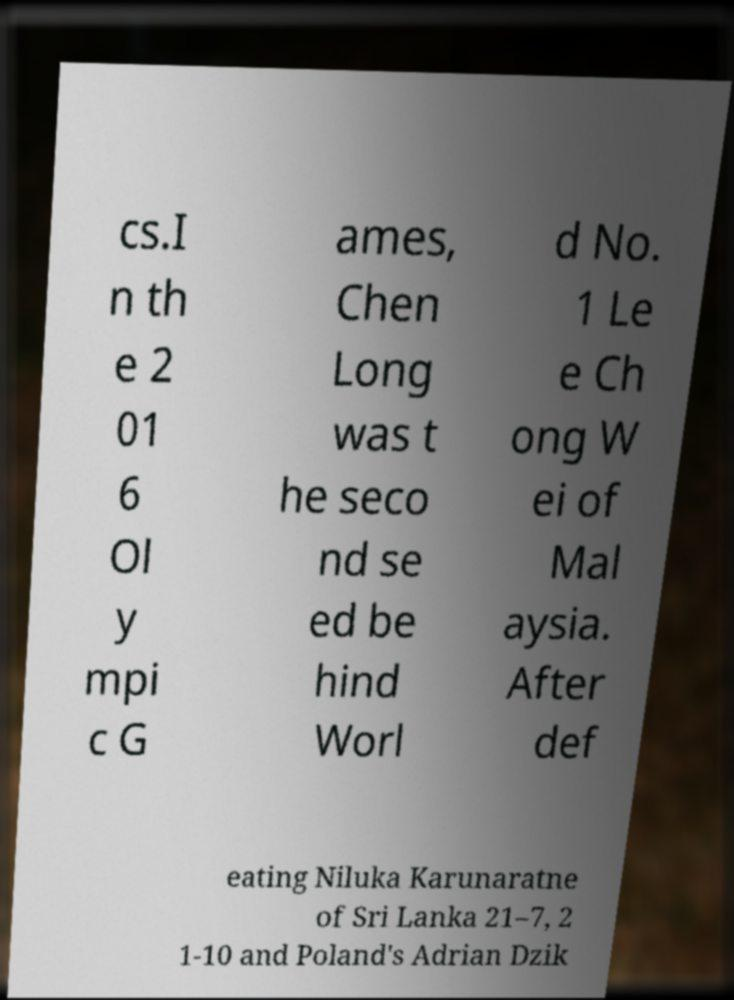Can you read and provide the text displayed in the image?This photo seems to have some interesting text. Can you extract and type it out for me? cs.I n th e 2 01 6 Ol y mpi c G ames, Chen Long was t he seco nd se ed be hind Worl d No. 1 Le e Ch ong W ei of Mal aysia. After def eating Niluka Karunaratne of Sri Lanka 21–7, 2 1-10 and Poland's Adrian Dzik 